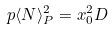Convert formula to latex. <formula><loc_0><loc_0><loc_500><loc_500>p \langle N \rangle _ { P } ^ { 2 } = x _ { 0 } ^ { 2 } D</formula> 